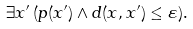Convert formula to latex. <formula><loc_0><loc_0><loc_500><loc_500>\exists x ^ { \prime } \, ( p ( x ^ { \prime } ) \wedge d ( x , x ^ { \prime } ) \leq \varepsilon ) .</formula> 